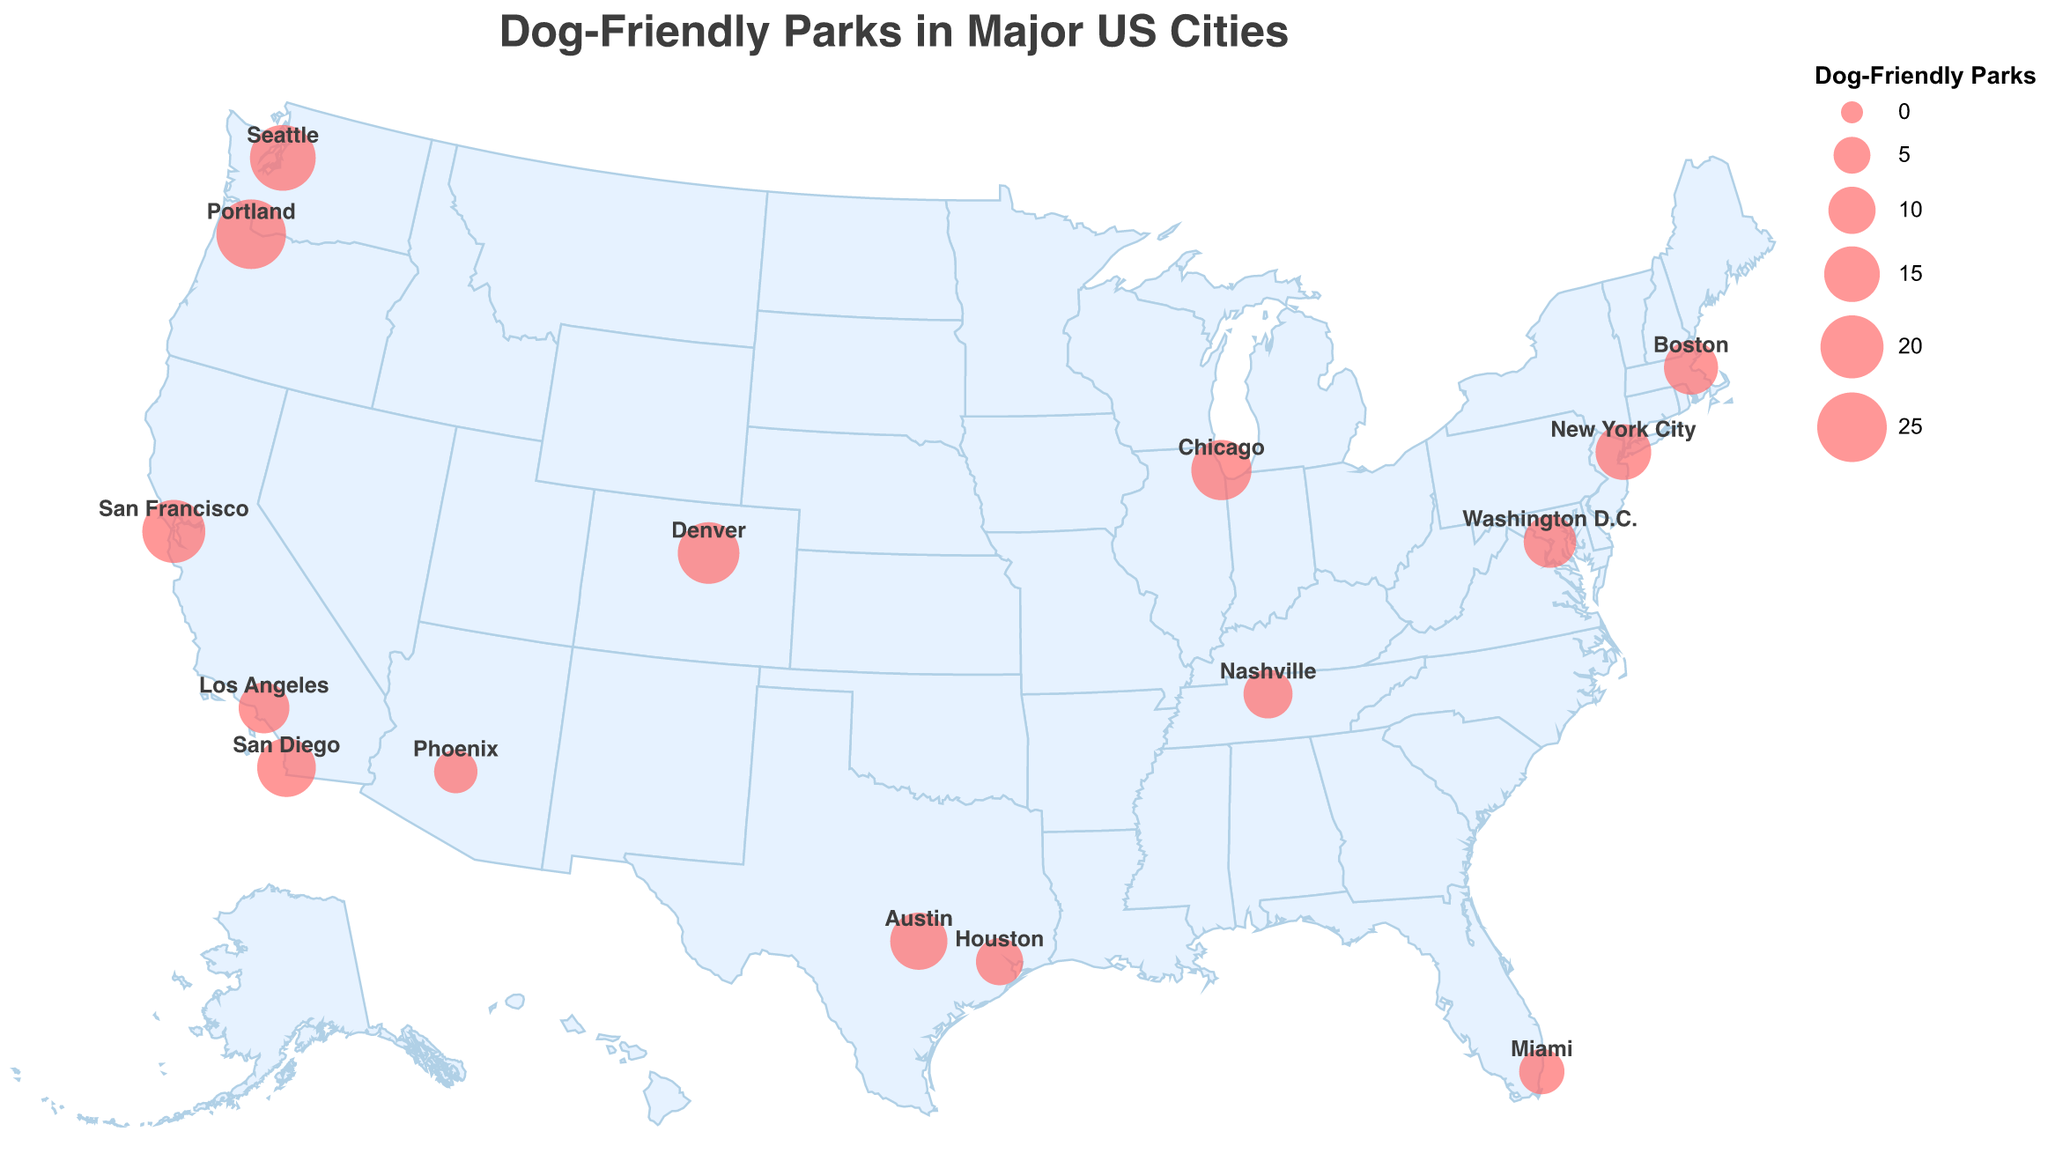Which city has the most dog-friendly parks? By looking at the plotted circles, we see that Portland has the largest circle size. The tooltip also confirms that Portland has 25 dog-friendly parks.
Answer: Portland Which city has the highest average rating for its dog-friendly parks? By examining the figure, we see that Portland has the highest rating of 4.9 among the listed cities. This can be confirmed by checking the tooltip.
Answer: Portland How many more dog-friendly parks does Denver have compared to Houston? Denver is represented with 19 dog-friendly parks while Houston has 10. Subtracting the two, 19 - 10, gives 9.
Answer: 9 Which city, Austin or Miami, has a higher rating for its dog-friendly parks? From the tooltip, Austin has a rating of 4.6 while Miami has a rating of 3.8. Austin's rating is higher.
Answer: Austin How many cities have at least 15 dog-friendly parks? By referring to the circle sizes and tooltips, the cities with at least 15 parks are New York City, Chicago, San Francisco, Seattle, Austin, Denver, Portland, and San Diego. That's a total of 8 cities.
Answer: 8 Which city is marked by the northernmost point on the map? By examining the geographic positions, Seattle is the northernmost city on the map.
Answer: Seattle Compare the combined number of dog-friendly parks in Los Angeles and San Francisco to those in New York City and Boston. Which group has more parks? Los Angeles has 12 parks, San Francisco has 20, New York City has 15, and Boston has 14. Adding these, Los Angeles + San Francisco = 32, and New York City + Boston = 29. Thus, the first group has more parks.
Answer: Los Angeles and San Francisco What is the average rating of dog-friendly parks for cities with exactly 12 or fewer parks? First identify the cities: Los Angeles, Houston, Phoenix, Miami, and Nashville with respective ratings of 4.5, 3.9, 4.1, 3.8, and 4.0. Add these and divide by 5. (4.5 + 3.9 + 4.1 + 3.8 + 4.0) / 5 = 20.3 / 5 = 4.06.
Answer: 4.06 Which city lies the farthest to the east on the map? By looking at the longitude values, Boston is the farthest east among the cities listed.
Answer: Boston 